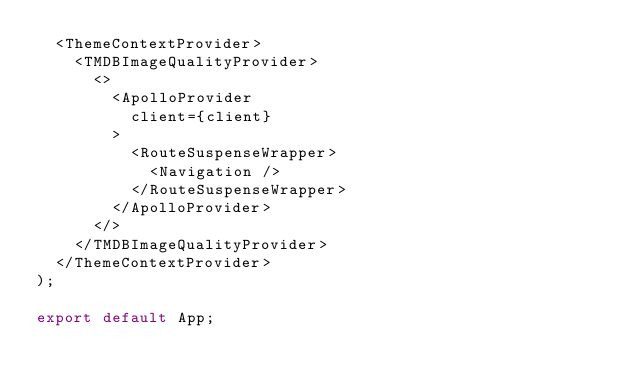<code> <loc_0><loc_0><loc_500><loc_500><_TypeScript_>  <ThemeContextProvider>
    <TMDBImageQualityProvider>
      <>
        <ApolloProvider
          client={client}
        >
          <RouteSuspenseWrapper>
            <Navigation />
          </RouteSuspenseWrapper>
        </ApolloProvider>
      </>
    </TMDBImageQualityProvider>
  </ThemeContextProvider>
);

export default App;
</code> 